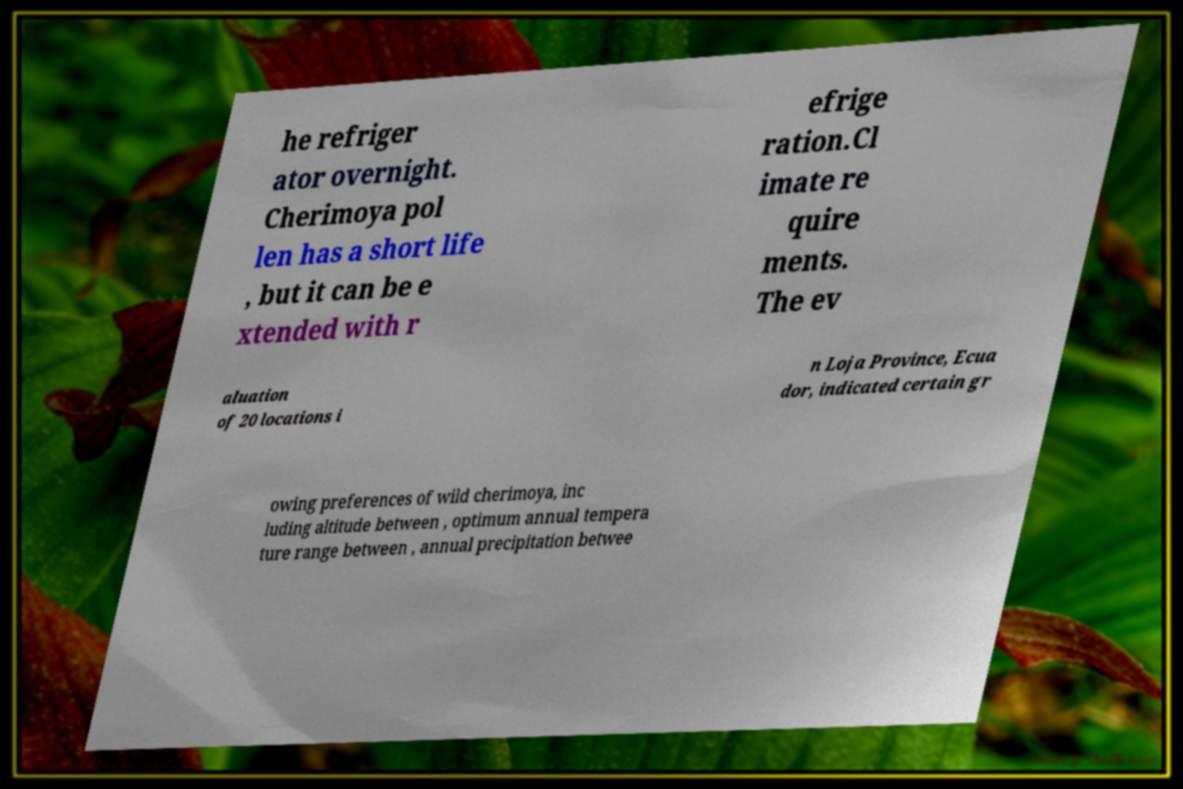There's text embedded in this image that I need extracted. Can you transcribe it verbatim? he refriger ator overnight. Cherimoya pol len has a short life , but it can be e xtended with r efrige ration.Cl imate re quire ments. The ev aluation of 20 locations i n Loja Province, Ecua dor, indicated certain gr owing preferences of wild cherimoya, inc luding altitude between , optimum annual tempera ture range between , annual precipitation betwee 